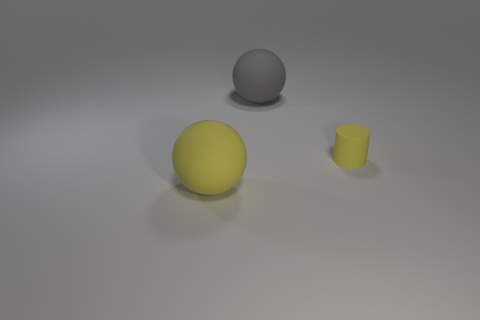Are there any big things that have the same material as the yellow ball?
Offer a very short reply. Yes. How many gray objects are small matte cylinders or big rubber spheres?
Your answer should be very brief. 1. There is a object that is both in front of the big gray rubber ball and on the left side of the tiny yellow cylinder; what size is it?
Provide a short and direct response. Large. Are there more tiny matte cylinders behind the small yellow cylinder than yellow rubber cylinders?
Provide a short and direct response. No. What number of balls are either large objects or gray rubber objects?
Offer a very short reply. 2. There is a rubber object that is left of the tiny yellow cylinder and behind the large yellow object; what shape is it?
Provide a short and direct response. Sphere. Are there an equal number of matte cylinders to the left of the small object and large yellow matte things behind the big yellow object?
Keep it short and to the point. Yes. How many objects are big yellow things or small yellow objects?
Your response must be concise. 2. There is a thing that is the same size as the gray ball; what is its color?
Your response must be concise. Yellow. What number of things are large objects right of the big yellow sphere or things that are in front of the large gray sphere?
Keep it short and to the point. 3. 